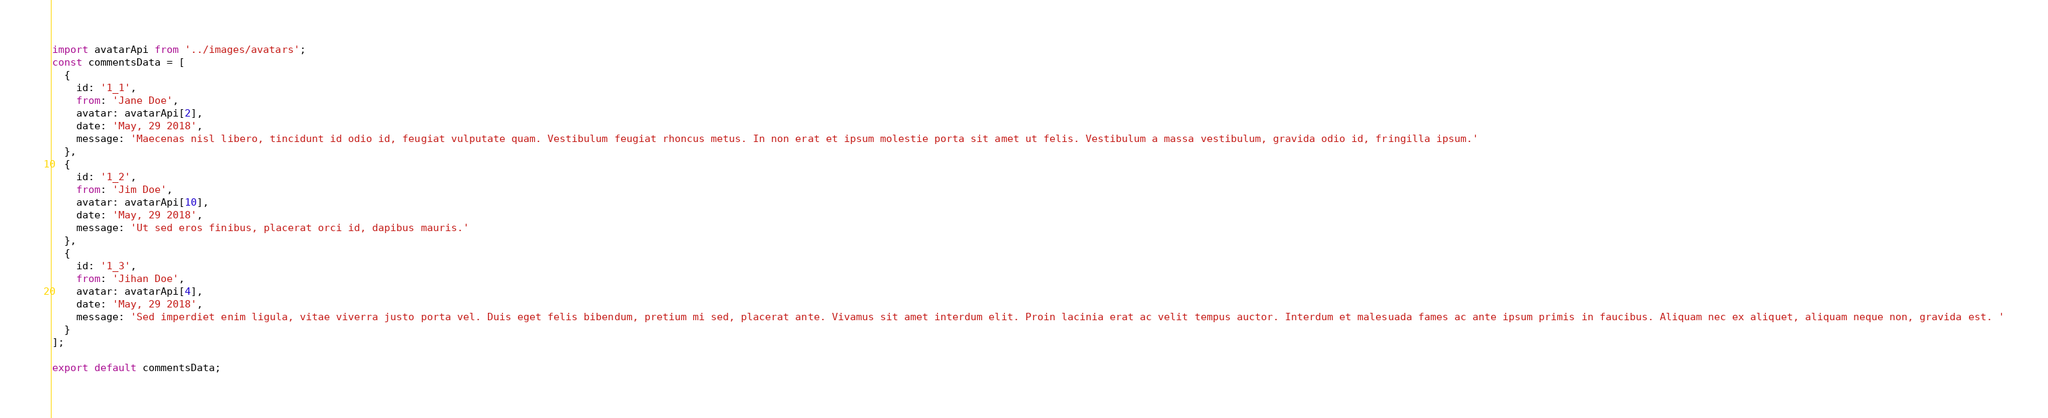<code> <loc_0><loc_0><loc_500><loc_500><_JavaScript_>import avatarApi from '../images/avatars';
const commentsData = [
  {
    id: '1_1',
    from: 'Jane Doe',
    avatar: avatarApi[2],
    date: 'May, 29 2018',
    message: 'Maecenas nisl libero, tincidunt id odio id, feugiat vulputate quam. Vestibulum feugiat rhoncus metus. In non erat et ipsum molestie porta sit amet ut felis. Vestibulum a massa vestibulum, gravida odio id, fringilla ipsum.'
  },
  {
    id: '1_2',
    from: 'Jim Doe',
    avatar: avatarApi[10],
    date: 'May, 29 2018',
    message: 'Ut sed eros finibus, placerat orci id, dapibus mauris.'
  },
  {
    id: '1_3',
    from: 'Jihan Doe',
    avatar: avatarApi[4],
    date: 'May, 29 2018',
    message: 'Sed imperdiet enim ligula, vitae viverra justo porta vel. Duis eget felis bibendum, pretium mi sed, placerat ante. Vivamus sit amet interdum elit. Proin lacinia erat ac velit tempus auctor. Interdum et malesuada fames ac ante ipsum primis in faucibus. Aliquam nec ex aliquet, aliquam neque non, gravida est. '
  }
];

export default commentsData;
</code> 